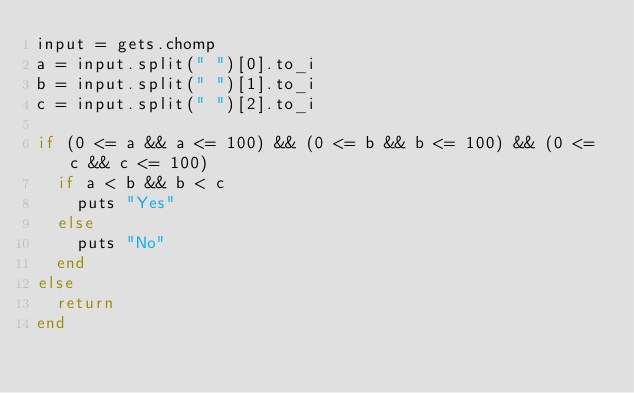<code> <loc_0><loc_0><loc_500><loc_500><_Ruby_>input = gets.chomp
a = input.split(" ")[0].to_i
b = input.split(" ")[1].to_i
c = input.split(" ")[2].to_i

if (0 <= a && a <= 100) && (0 <= b && b <= 100) && (0 <= c && c <= 100)
  if a < b && b < c
    puts "Yes"
  else
    puts "No"
  end
else
  return
end

</code> 